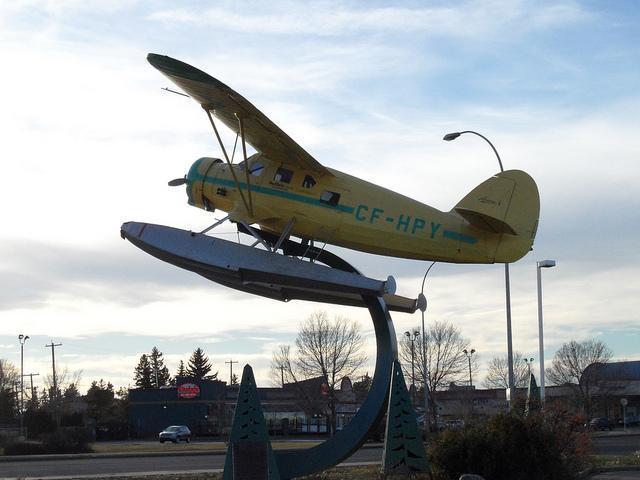How many airplanes are in the picture?
Give a very brief answer. 1. How many benches are in the photo?
Give a very brief answer. 0. 